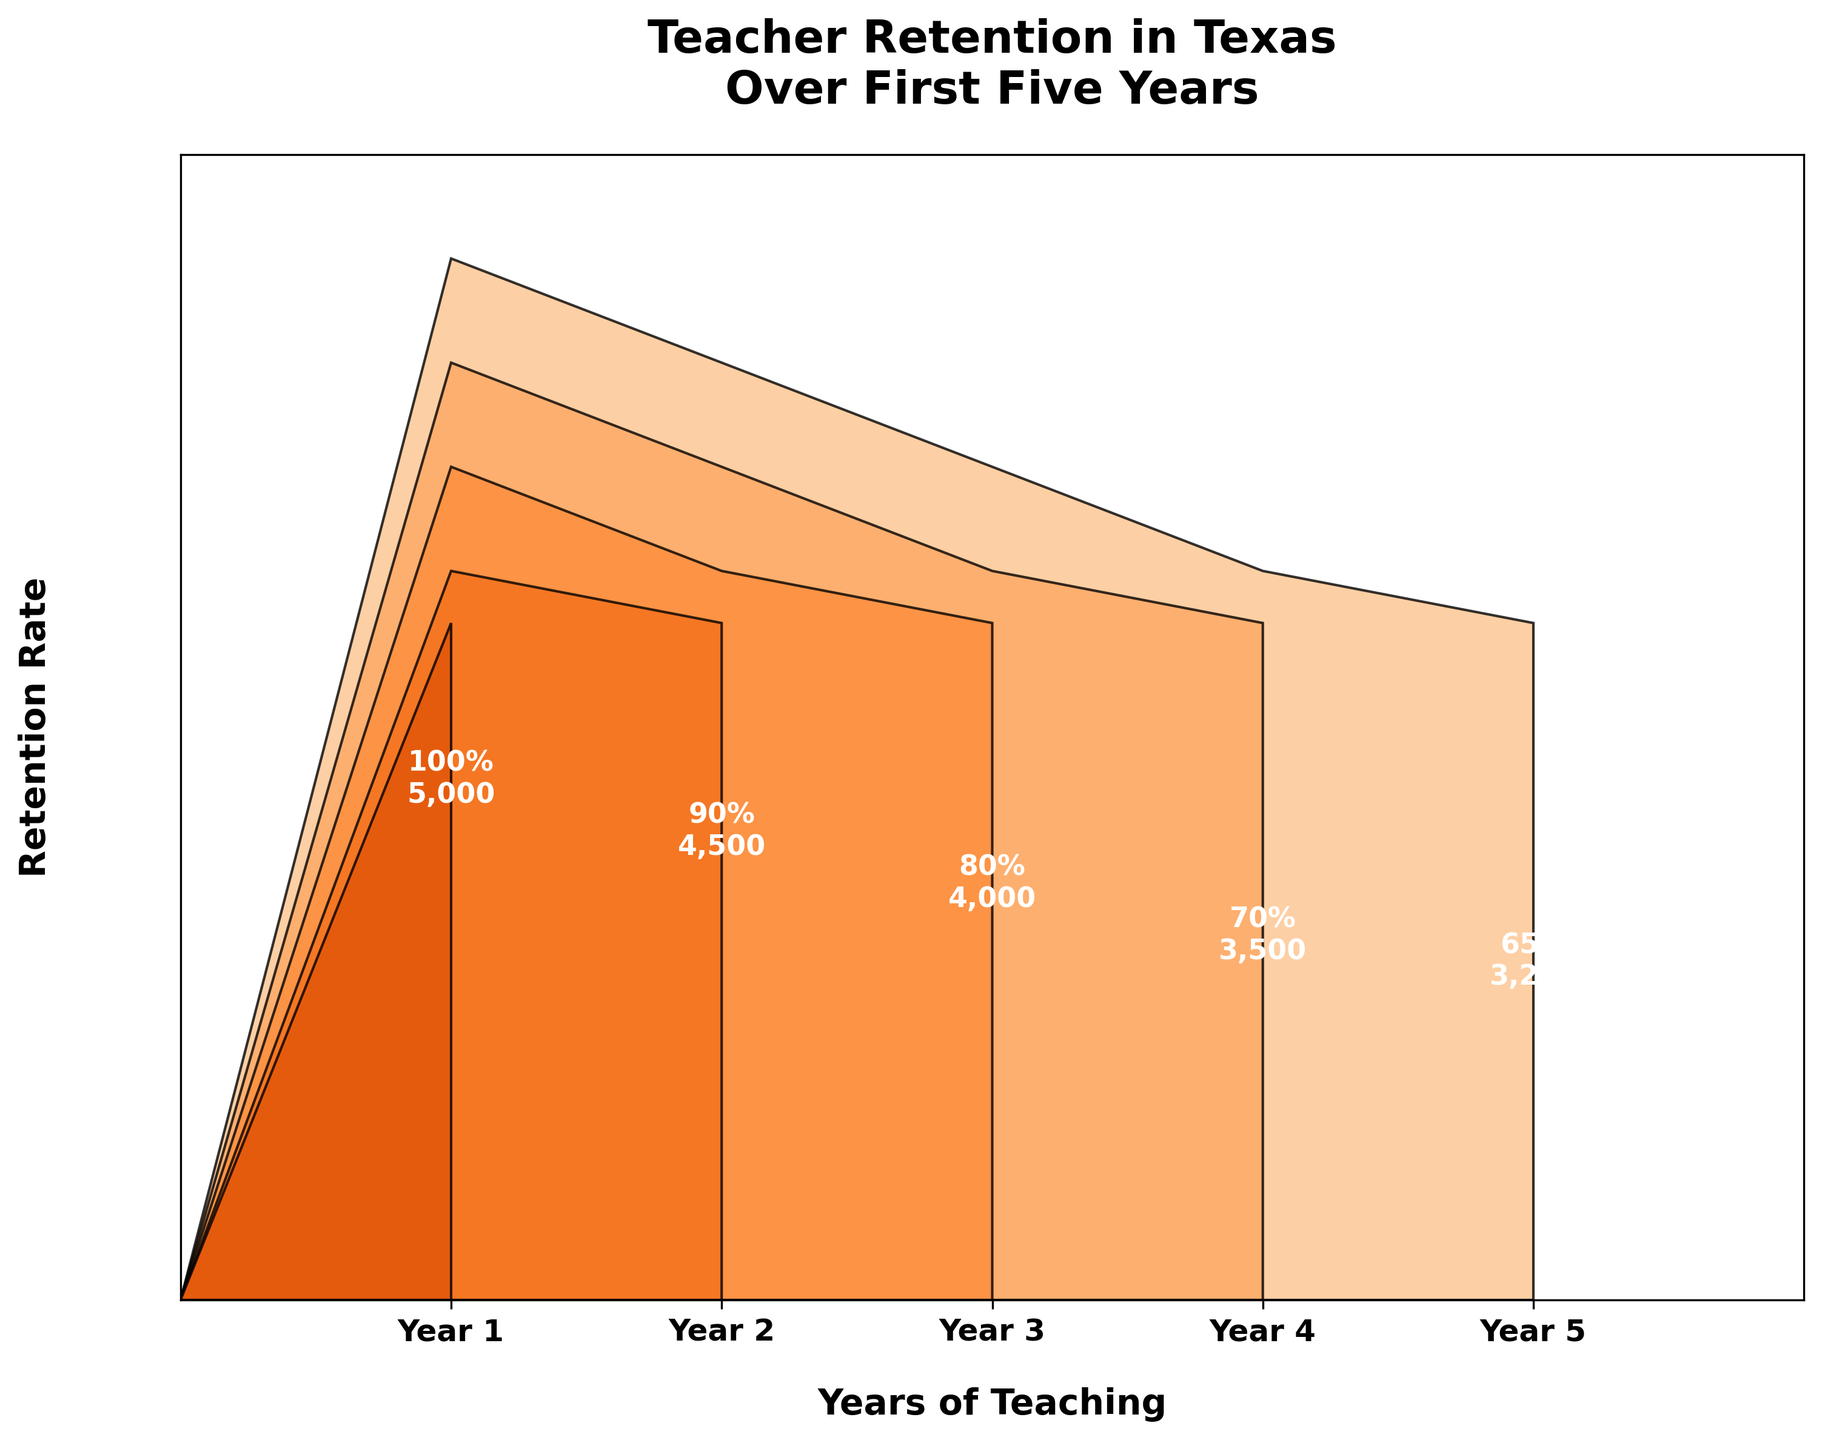What's the title of the figure? The title of a chart is usually displayed at the top. In this figure, it reads "Teacher Retention in Texas Over First Five Years."
Answer: Teacher Retention in Texas Over First Five Years How many years are tracked in the figure? The x-axis of the chart shows the years being tracked. Each bar represents a year from the first year to the fifth year. Count these years to find the total.
Answer: 5 What is the retention rate at the end of Year 3? Look for the label within the funnel chart corresponding to Year 3; it shows the retention rate as a percentage.
Answer: 80% Which year shows the greatest decrease in the number of teachers remaining? Compare the number of teachers remaining for each year to the previous year. The year with the largest drop indicates the greatest decrease.
Answer: Year 1 to Year 2 How does the retention rate from Year 4 to Year 5 compare with the retention rate from Year 2 to Year 3? Look at the percentage retention rates between Year 4 and Year 5 and compare it with the retention rates between Year 2 and Year 3. Find the difference in each case.
Answer: Year 4 to Year 5 decrease is less than Year 2 to Year 3 decrease What proportion of the original 5000 teachers remain by the end of Year 5? The chart shows the number of teachers remaining each year. The number of teachers remaining by the end of Year 5 can be compared with the original number to find the proportion. \( \frac{3250}{5000} \)
Answer: 65% What is the overall retention rate change from Year 1 to Year 5? To calculate the overall change, find the retention rates for Year 1 and Year 5, and then find the difference between these two rates. 100% - 65% = 35%
Answer: 35% How many teachers left after Year 2? Subtract the number of teachers remaining after Year 2 from the original number of teachers. 5000 - 4500 = 500
Answer: 500 Compare the number of teachers remaining at the end of Year 3 and Year 4. Which year retained more teachers? Look at the number of teachers remaining at the end of Year 3 and Year 4. Compare these numbers directly.
Answer: Year 3 What is the range of the retention rates over the five years? Identify the highest and lowest retention rates in the figure and subtract the lowest rate from the highest one. 100% - 65% = 35%
Answer: 35% 